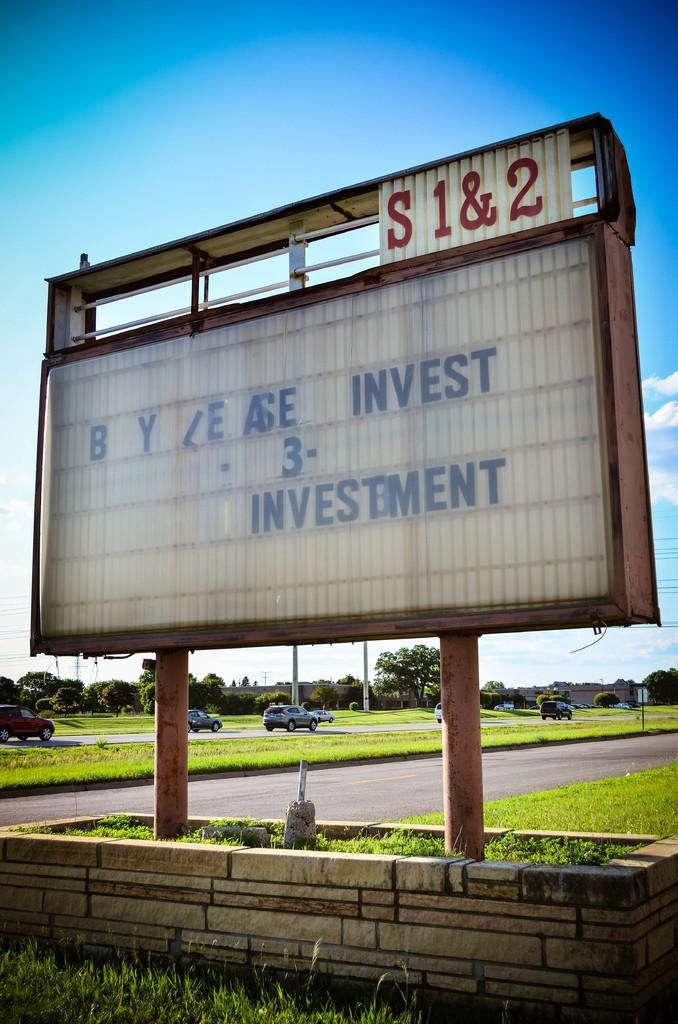What is on the wall in the image? There is a name board on the wall in the image. What can be seen on the road in the image? Vehicles are visible on the road in the image. What type of landscape is present on either side of the road? Grassland is present on either side of the road in the image. What is visible in the background of the image? There are trees in the background of the image. What is visible above the scene in the image? The sky is visible above the scene in the image. What type of riddle is written on the name board in the image? There is no riddle written on the name board in the image; it simply displays a name. How many shoes are visible on the road in the image? There are no shoes visible on the road in the image. 